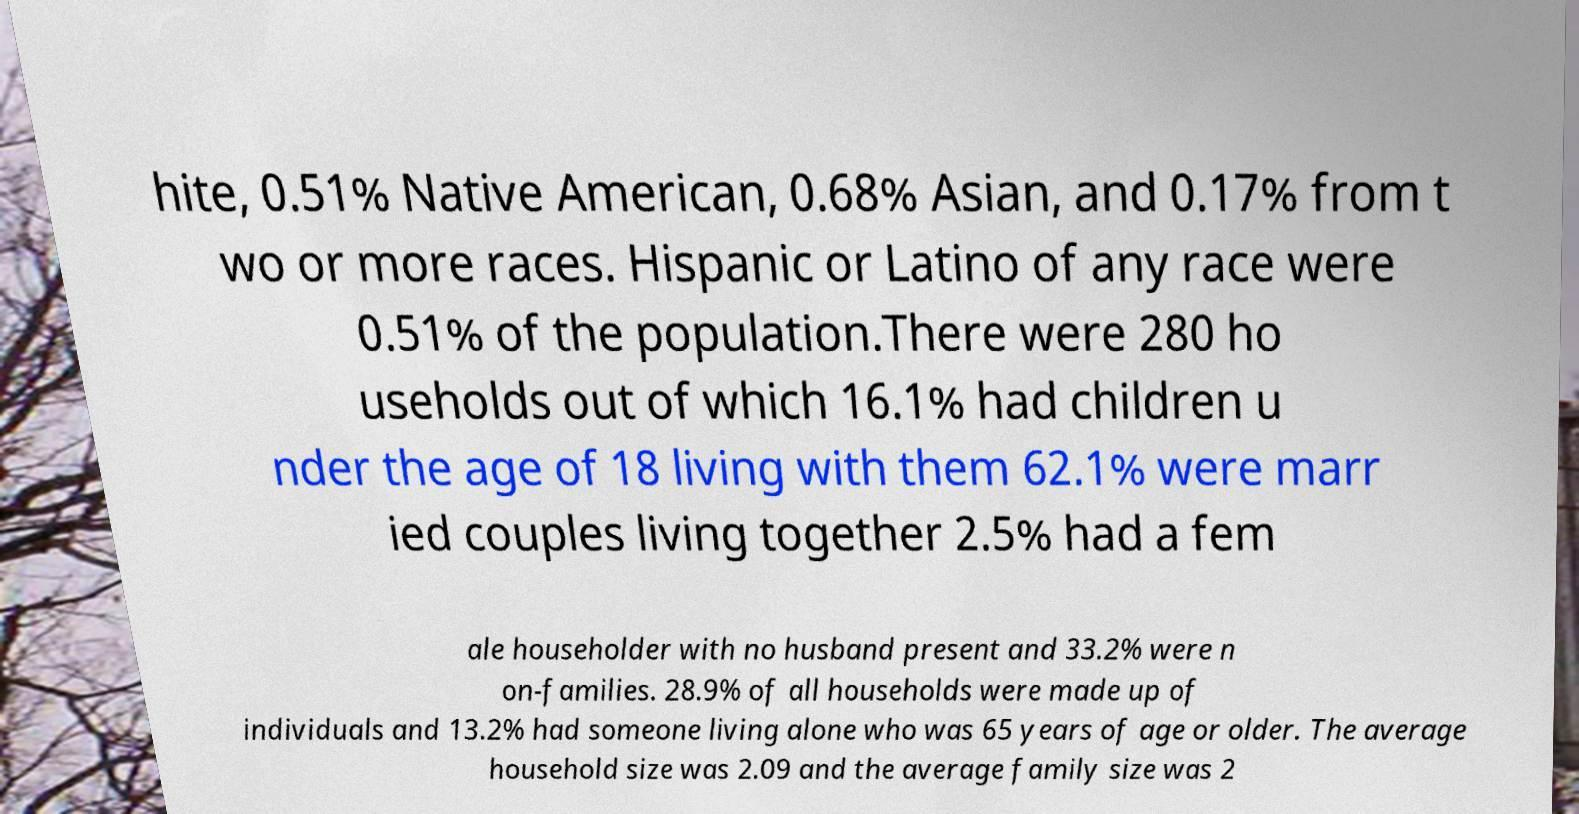For documentation purposes, I need the text within this image transcribed. Could you provide that? hite, 0.51% Native American, 0.68% Asian, and 0.17% from t wo or more races. Hispanic or Latino of any race were 0.51% of the population.There were 280 ho useholds out of which 16.1% had children u nder the age of 18 living with them 62.1% were marr ied couples living together 2.5% had a fem ale householder with no husband present and 33.2% were n on-families. 28.9% of all households were made up of individuals and 13.2% had someone living alone who was 65 years of age or older. The average household size was 2.09 and the average family size was 2 